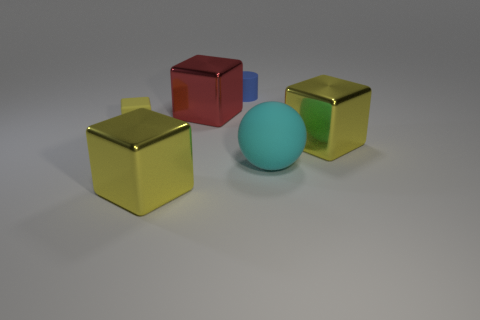Is the large red block made of the same material as the ball?
Your answer should be compact. No. How many objects are made of the same material as the cylinder?
Make the answer very short. 2. The small cube that is the same material as the small blue cylinder is what color?
Ensure brevity in your answer.  Yellow. What shape is the cyan thing?
Provide a succinct answer. Sphere. What material is the large yellow thing behind the big sphere?
Your answer should be very brief. Metal. Are there any cubes of the same color as the large matte object?
Ensure brevity in your answer.  No. There is a yellow thing that is the same size as the blue object; what is its shape?
Provide a short and direct response. Cube. What is the color of the thing right of the big cyan rubber thing?
Give a very brief answer. Yellow. Is there a red object behind the small blue thing on the left side of the large ball?
Give a very brief answer. No. What number of things are either yellow blocks that are behind the large cyan rubber sphere or blue metallic cylinders?
Make the answer very short. 2. 